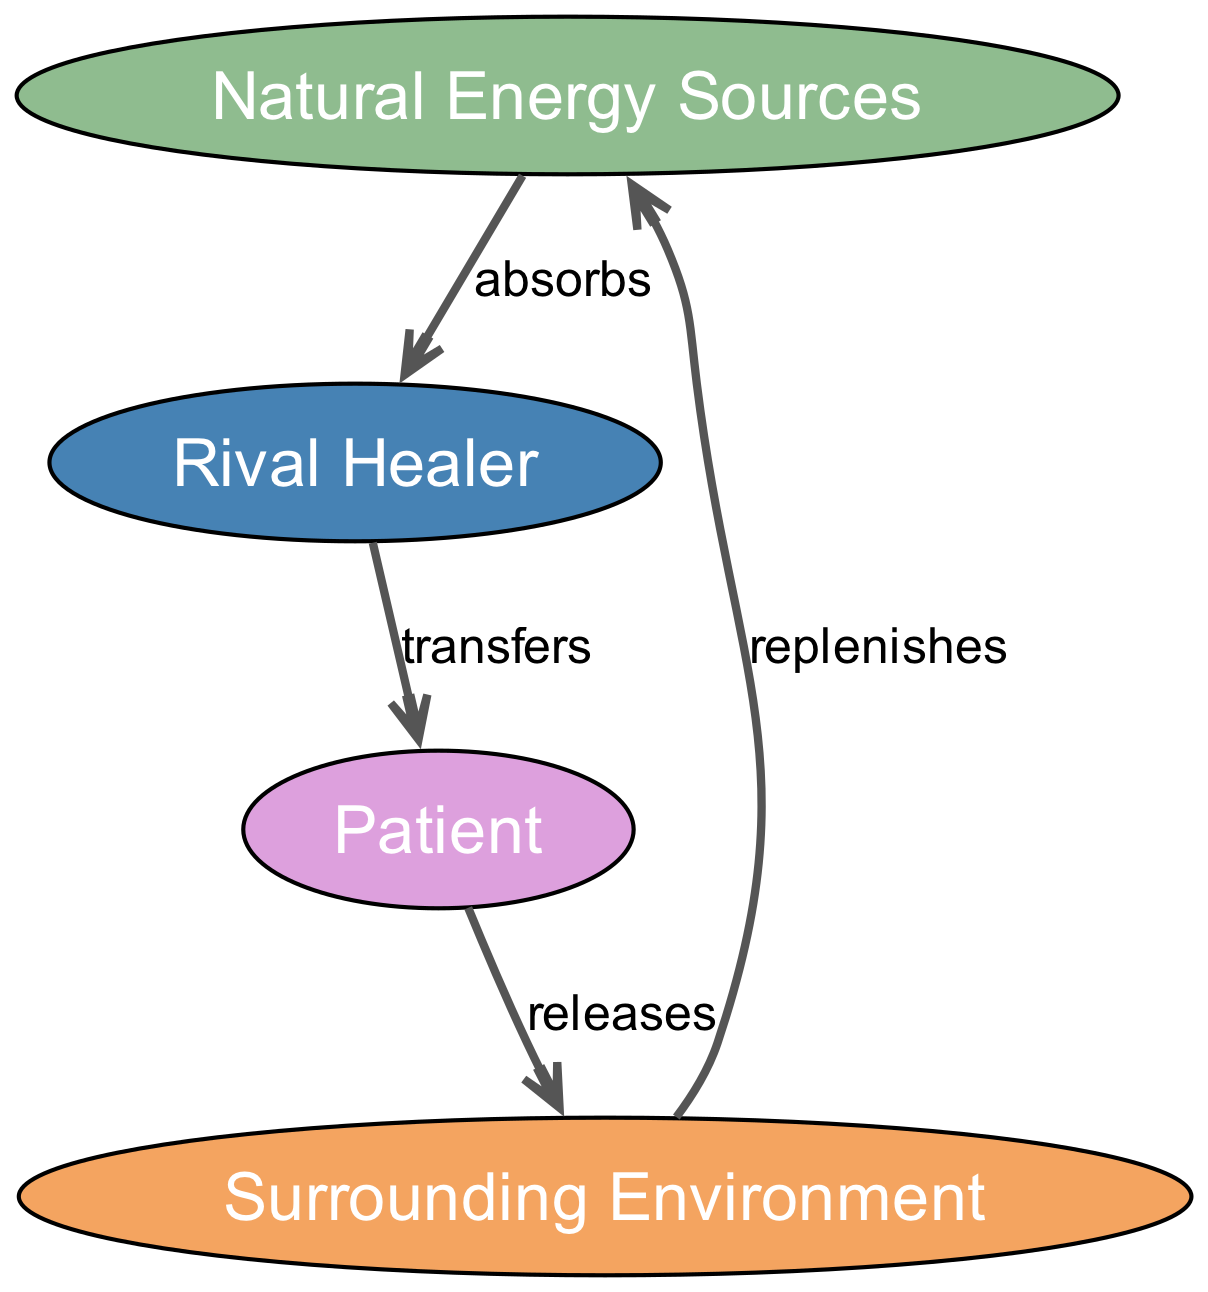What are the four main elements in the diagram? The diagram lists four elements: Natural Energy Sources, Rival Healer, Patient, and Surrounding Environment.
Answer: Natural Energy Sources, Rival Healer, Patient, Surrounding Environment How many edges connect the Rival Healer to other nodes? The Rival Healer has two outgoing edges: one to the Patient and one from Natural Energy Sources. Therefore, it connects to two other nodes.
Answer: 2 What type of relationship does the Rival Healer have with the Patient? According to the edge description, the Rival Healer "transfers" energy to the Patient, indicating a direct relationship of transfer.
Answer: transfers Which element replenishes the Natural Energy Sources? The Surrounding Environment is indicated as the element that "replenishes" the Natural Energy Sources, establishing a cyclical relationship.
Answer: Surrounding Environment What is the flow of energy from Natural Energy Sources to Patient? The flow begins at the Natural Energy Sources, which are absorbed by the Rival Healer, who then transfers this energy to the Patient. This sequence illustrates the path of energy transfer in the diagram.
Answer: absorbs, transfers Which element releases energy back into the cycle? The Patient is the element that releases energy back into the cycle, which then impacts the Surrounding Environment.
Answer: Patient What is the edge relationship between Patient and Surrounding Environment? The diagram specifies that the relationship is "releases," indicating that the Patient releases energy into the Surrounding Environment.
Answer: releases How does the Surrounding Environment affect the cycle? The Surrounding Environment replenishes the Natural Energy Sources, effectively completing the energy cycle and ensuring continuity of energy flow.
Answer: replenishes What is the role of the Rival Healer in this energy transfer cycle? The Rival Healer acts as an intermediary, absorbing energy from Natural Energy Sources and transferring it to the Patient, facilitating the flow of energy.
Answer: intermediary 